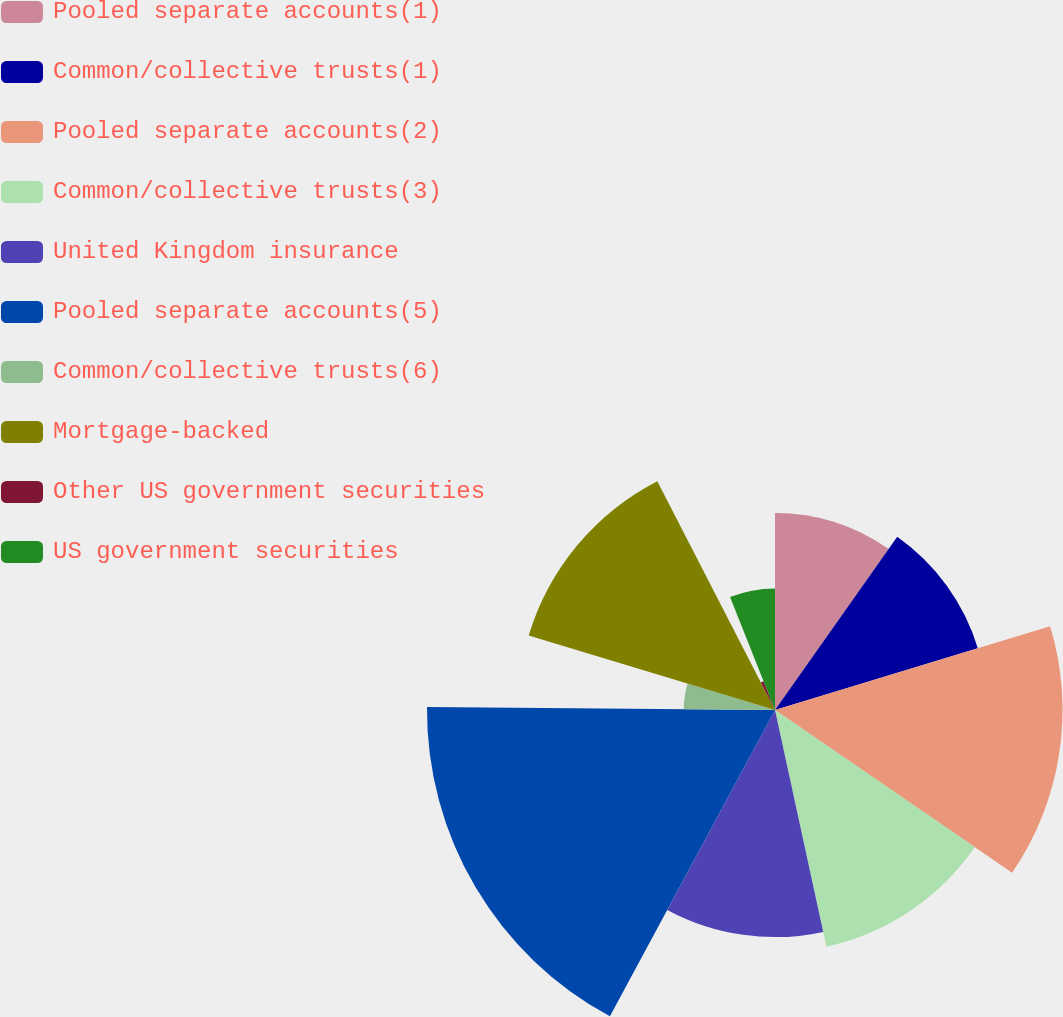Convert chart to OTSL. <chart><loc_0><loc_0><loc_500><loc_500><pie_chart><fcel>Pooled separate accounts(1)<fcel>Common/collective trusts(1)<fcel>Pooled separate accounts(2)<fcel>Common/collective trusts(3)<fcel>United Kingdom insurance<fcel>Pooled separate accounts(5)<fcel>Common/collective trusts(6)<fcel>Mortgage-backed<fcel>Other US government securities<fcel>US government securities<nl><fcel>9.78%<fcel>10.52%<fcel>14.27%<fcel>12.02%<fcel>11.27%<fcel>17.27%<fcel>4.53%<fcel>12.77%<fcel>1.53%<fcel>6.03%<nl></chart> 